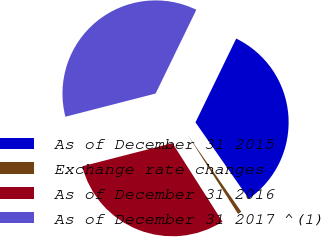Convert chart to OTSL. <chart><loc_0><loc_0><loc_500><loc_500><pie_chart><fcel>As of December 31 2015<fcel>Exchange rate changes<fcel>As of December 31 2016<fcel>As of December 31 2017 ^(1)<nl><fcel>33.11%<fcel>0.67%<fcel>30.02%<fcel>36.21%<nl></chart> 